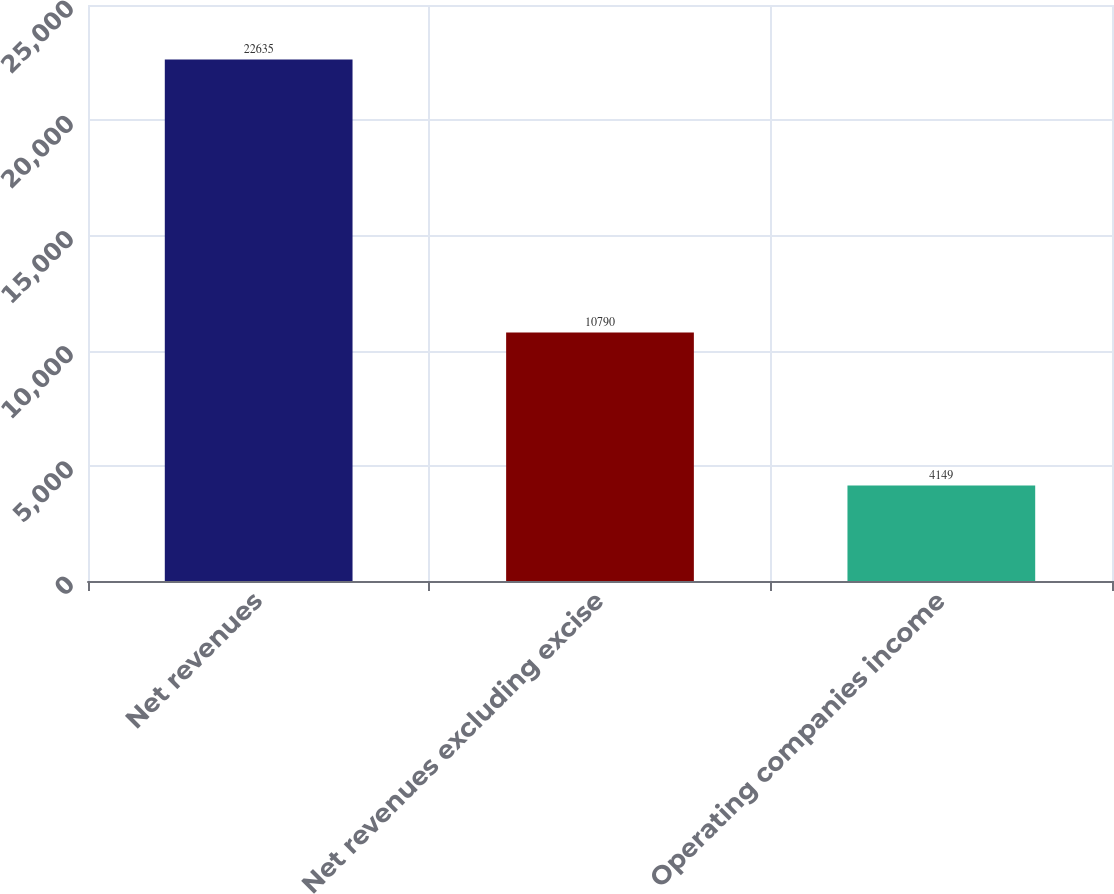Convert chart. <chart><loc_0><loc_0><loc_500><loc_500><bar_chart><fcel>Net revenues<fcel>Net revenues excluding excise<fcel>Operating companies income<nl><fcel>22635<fcel>10790<fcel>4149<nl></chart> 